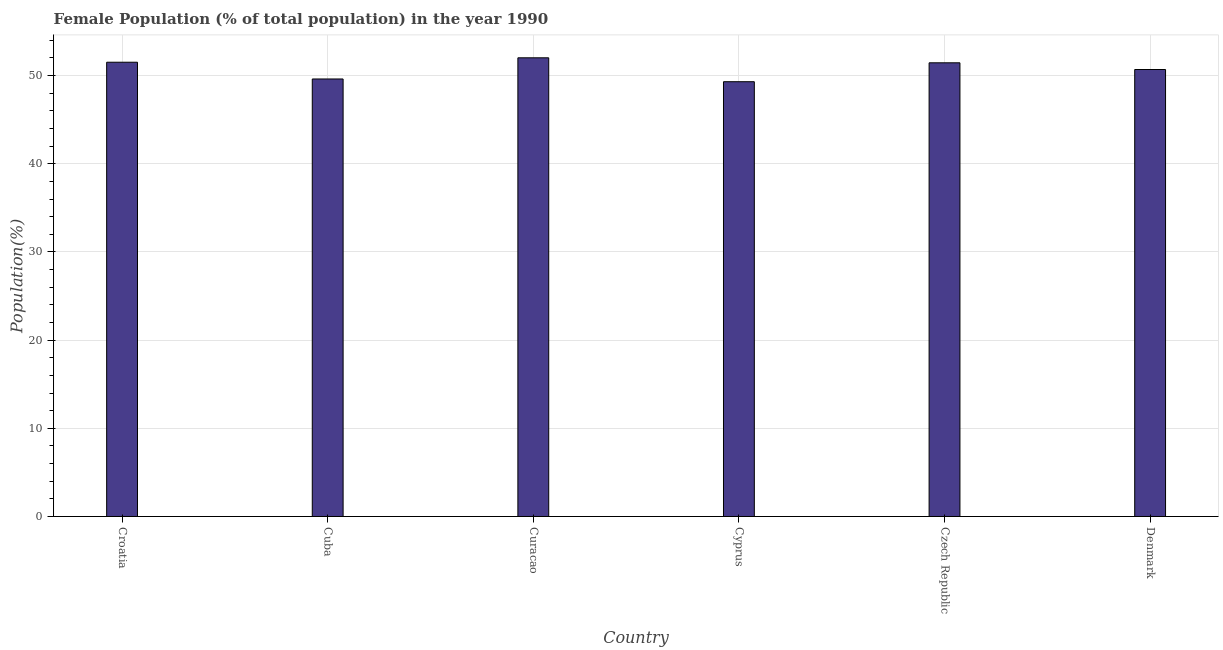What is the title of the graph?
Your answer should be compact. Female Population (% of total population) in the year 1990. What is the label or title of the X-axis?
Give a very brief answer. Country. What is the label or title of the Y-axis?
Your answer should be very brief. Population(%). What is the female population in Croatia?
Provide a short and direct response. 51.52. Across all countries, what is the maximum female population?
Make the answer very short. 52.02. Across all countries, what is the minimum female population?
Provide a succinct answer. 49.31. In which country was the female population maximum?
Offer a terse response. Curacao. In which country was the female population minimum?
Provide a short and direct response. Cyprus. What is the sum of the female population?
Offer a terse response. 304.6. What is the difference between the female population in Cyprus and Czech Republic?
Ensure brevity in your answer.  -2.15. What is the average female population per country?
Offer a terse response. 50.77. What is the median female population?
Ensure brevity in your answer.  51.07. In how many countries, is the female population greater than 50 %?
Offer a terse response. 4. Is the female population in Curacao less than that in Czech Republic?
Your answer should be compact. No. What is the difference between the highest and the second highest female population?
Your answer should be compact. 0.5. What is the difference between the highest and the lowest female population?
Your answer should be very brief. 2.71. How many bars are there?
Offer a very short reply. 6. Are the values on the major ticks of Y-axis written in scientific E-notation?
Your answer should be compact. No. What is the Population(%) in Croatia?
Give a very brief answer. 51.52. What is the Population(%) of Cuba?
Offer a very short reply. 49.62. What is the Population(%) of Curacao?
Your answer should be very brief. 52.02. What is the Population(%) in Cyprus?
Ensure brevity in your answer.  49.31. What is the Population(%) in Czech Republic?
Ensure brevity in your answer.  51.45. What is the Population(%) in Denmark?
Give a very brief answer. 50.69. What is the difference between the Population(%) in Croatia and Cuba?
Offer a very short reply. 1.9. What is the difference between the Population(%) in Croatia and Curacao?
Provide a short and direct response. -0.5. What is the difference between the Population(%) in Croatia and Cyprus?
Your answer should be very brief. 2.21. What is the difference between the Population(%) in Croatia and Czech Republic?
Your answer should be compact. 0.06. What is the difference between the Population(%) in Croatia and Denmark?
Keep it short and to the point. 0.82. What is the difference between the Population(%) in Cuba and Curacao?
Give a very brief answer. -2.4. What is the difference between the Population(%) in Cuba and Cyprus?
Offer a very short reply. 0.31. What is the difference between the Population(%) in Cuba and Czech Republic?
Make the answer very short. -1.83. What is the difference between the Population(%) in Cuba and Denmark?
Give a very brief answer. -1.07. What is the difference between the Population(%) in Curacao and Cyprus?
Provide a succinct answer. 2.71. What is the difference between the Population(%) in Curacao and Czech Republic?
Your answer should be very brief. 0.57. What is the difference between the Population(%) in Curacao and Denmark?
Your response must be concise. 1.33. What is the difference between the Population(%) in Cyprus and Czech Republic?
Provide a succinct answer. -2.14. What is the difference between the Population(%) in Cyprus and Denmark?
Make the answer very short. -1.38. What is the difference between the Population(%) in Czech Republic and Denmark?
Your answer should be compact. 0.76. What is the ratio of the Population(%) in Croatia to that in Cuba?
Give a very brief answer. 1.04. What is the ratio of the Population(%) in Croatia to that in Cyprus?
Your answer should be very brief. 1.04. What is the ratio of the Population(%) in Croatia to that in Czech Republic?
Offer a very short reply. 1. What is the ratio of the Population(%) in Croatia to that in Denmark?
Make the answer very short. 1.02. What is the ratio of the Population(%) in Cuba to that in Curacao?
Ensure brevity in your answer.  0.95. What is the ratio of the Population(%) in Cuba to that in Czech Republic?
Ensure brevity in your answer.  0.96. What is the ratio of the Population(%) in Cuba to that in Denmark?
Ensure brevity in your answer.  0.98. What is the ratio of the Population(%) in Curacao to that in Cyprus?
Your response must be concise. 1.05. What is the ratio of the Population(%) in Cyprus to that in Czech Republic?
Offer a terse response. 0.96. 